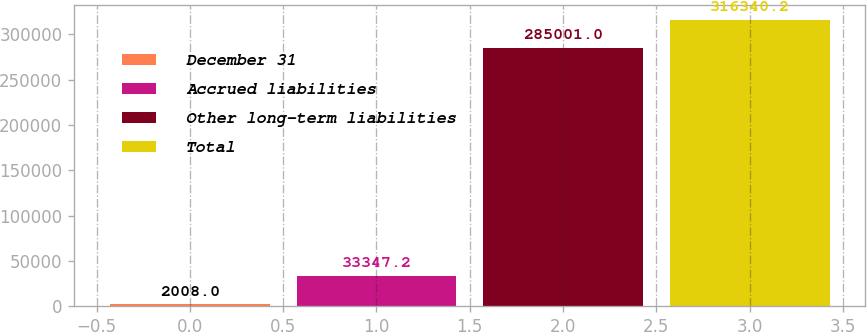Convert chart. <chart><loc_0><loc_0><loc_500><loc_500><bar_chart><fcel>December 31<fcel>Accrued liabilities<fcel>Other long-term liabilities<fcel>Total<nl><fcel>2008<fcel>33347.2<fcel>285001<fcel>316340<nl></chart> 